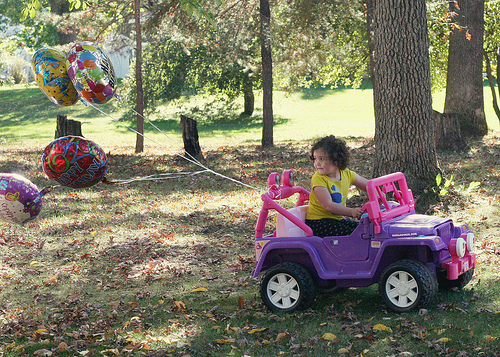<image>
Is the balloons on the car? Yes. Looking at the image, I can see the balloons is positioned on top of the car, with the car providing support. Is there a balloon above the tree? No. The balloon is not positioned above the tree. The vertical arrangement shows a different relationship. 